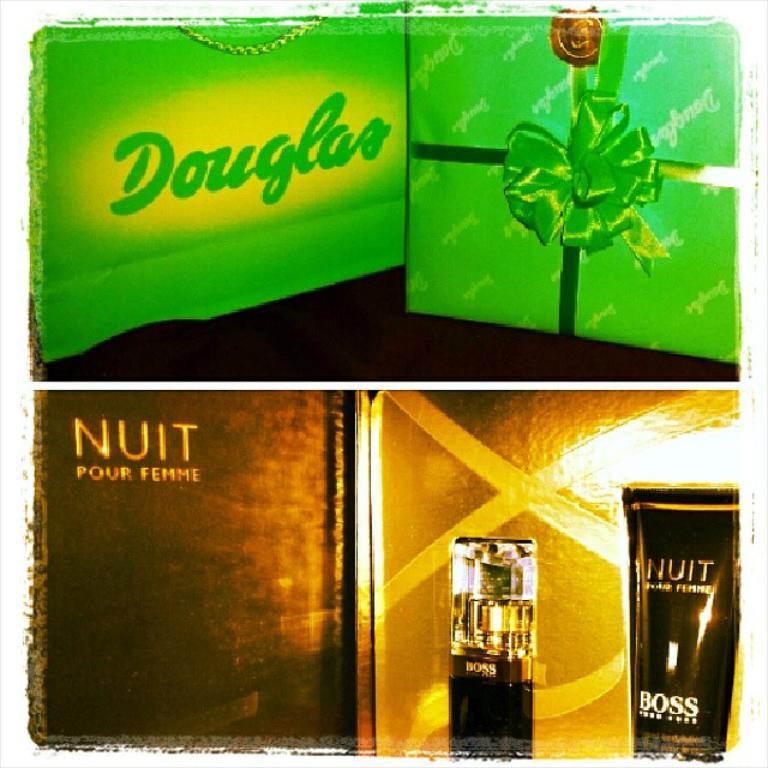Is this an ad?
Offer a terse response. Yes. What name is on the green sign at the top?
Offer a very short reply. Douglas. 